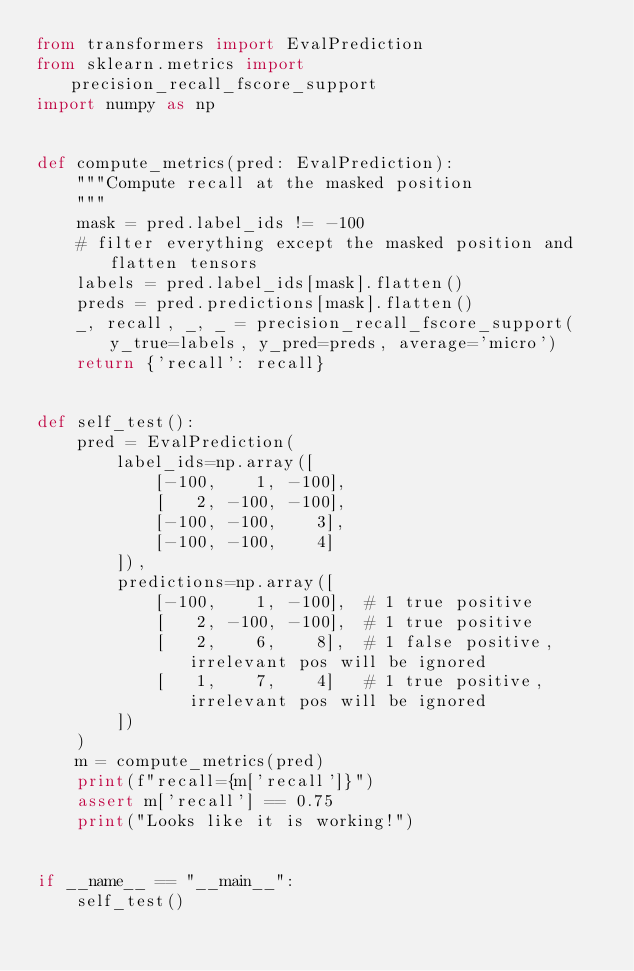<code> <loc_0><loc_0><loc_500><loc_500><_Python_>from transformers import EvalPrediction
from sklearn.metrics import precision_recall_fscore_support
import numpy as np


def compute_metrics(pred: EvalPrediction):
    """Compute recall at the masked position
    """
    mask = pred.label_ids != -100
    # filter everything except the masked position and flatten tensors
    labels = pred.label_ids[mask].flatten()
    preds = pred.predictions[mask].flatten()
    _, recall, _, _ = precision_recall_fscore_support(y_true=labels, y_pred=preds, average='micro')
    return {'recall': recall}


def self_test():
    pred = EvalPrediction(
        label_ids=np.array([
            [-100,    1, -100],
            [   2, -100, -100],
            [-100, -100,    3],
            [-100, -100,    4]
        ]),
        predictions=np.array([
            [-100,    1, -100],  # 1 true positive
            [   2, -100, -100],  # 1 true positive
            [   2,    6,    8],  # 1 false positive, irrelevant pos will be ignored
            [   1,    7,    4]   # 1 true positive, irrelevant pos will be ignored
        ]) 
    )
    m = compute_metrics(pred)
    print(f"recall={m['recall']}")
    assert m['recall'] == 0.75
    print("Looks like it is working!")


if __name__ == "__main__":
    self_test()
</code> 